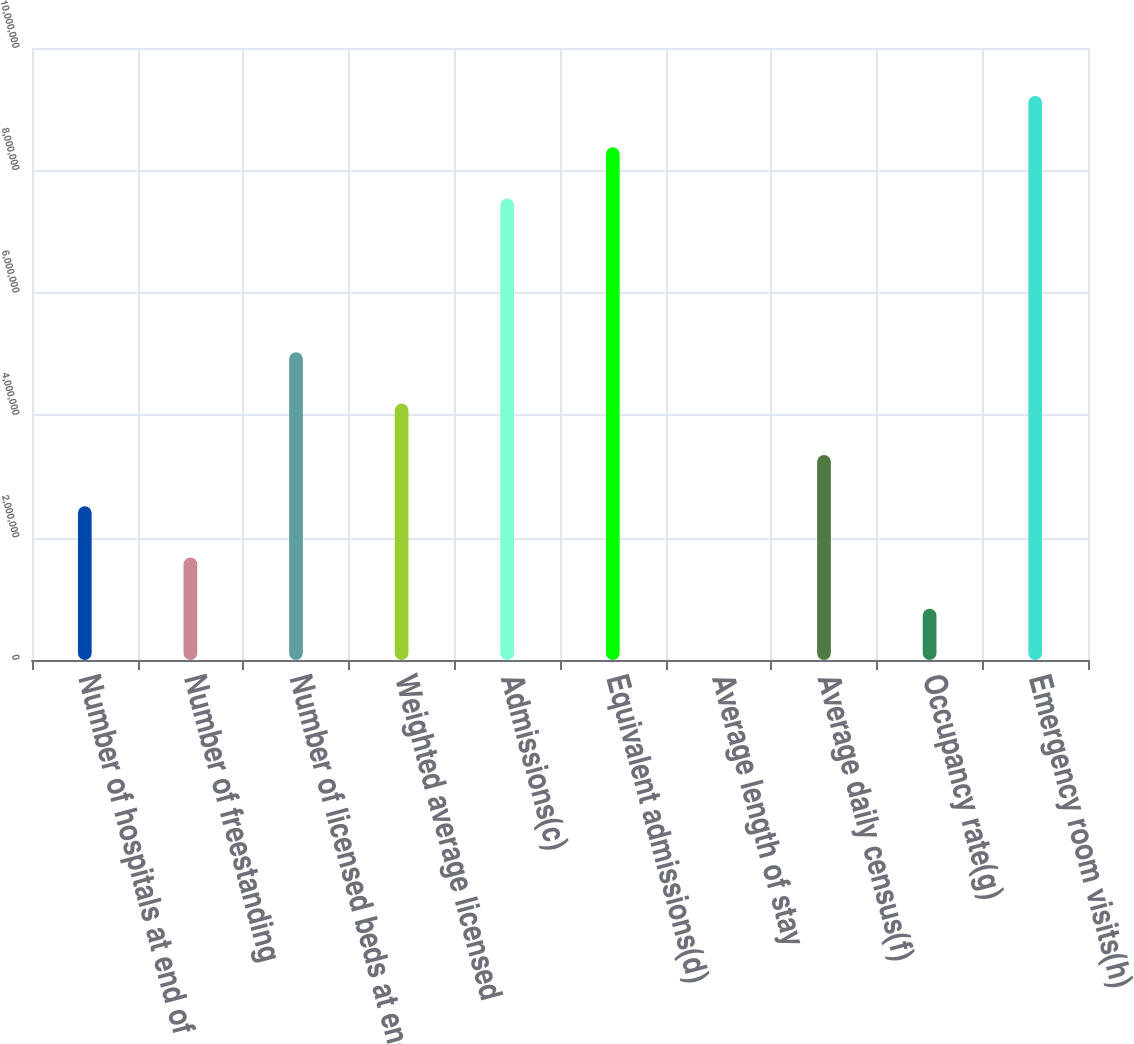Convert chart. <chart><loc_0><loc_0><loc_500><loc_500><bar_chart><fcel>Number of hospitals at end of<fcel>Number of freestanding<fcel>Number of licensed beds at end<fcel>Weighted average licensed<fcel>Admissions(c)<fcel>Equivalent admissions(d)<fcel>Average length of stay<fcel>Average daily census(f)<fcel>Occupancy rate(g)<fcel>Emergency room visits(h)<nl><fcel>2.51351e+06<fcel>1.67567e+06<fcel>5.02701e+06<fcel>4.18917e+06<fcel>7.54051e+06<fcel>8.37834e+06<fcel>4.9<fcel>3.35134e+06<fcel>837838<fcel>9.21617e+06<nl></chart> 